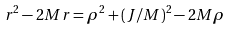<formula> <loc_0><loc_0><loc_500><loc_500>r ^ { 2 } - 2 M r = \rho ^ { 2 } + ( J / M ) ^ { 2 } - 2 M \rho</formula> 